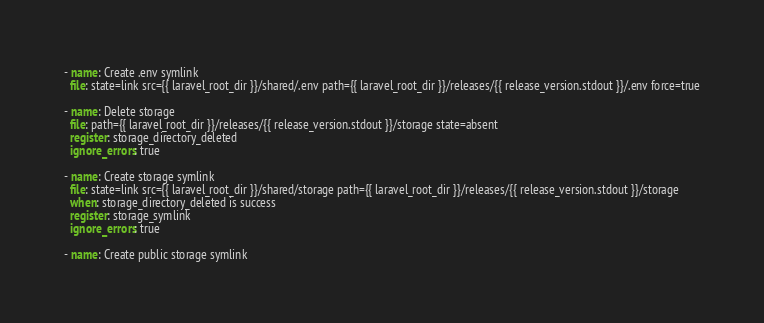Convert code to text. <code><loc_0><loc_0><loc_500><loc_500><_YAML_>- name: Create .env symlink
  file: state=link src={{ laravel_root_dir }}/shared/.env path={{ laravel_root_dir }}/releases/{{ release_version.stdout }}/.env force=true

- name: Delete storage
  file: path={{ laravel_root_dir }}/releases/{{ release_version.stdout }}/storage state=absent
  register: storage_directory_deleted
  ignore_errors: true

- name: Create storage symlink
  file: state=link src={{ laravel_root_dir }}/shared/storage path={{ laravel_root_dir }}/releases/{{ release_version.stdout }}/storage
  when: storage_directory_deleted is success
  register: storage_symlink
  ignore_errors: true

- name: Create public storage symlink</code> 